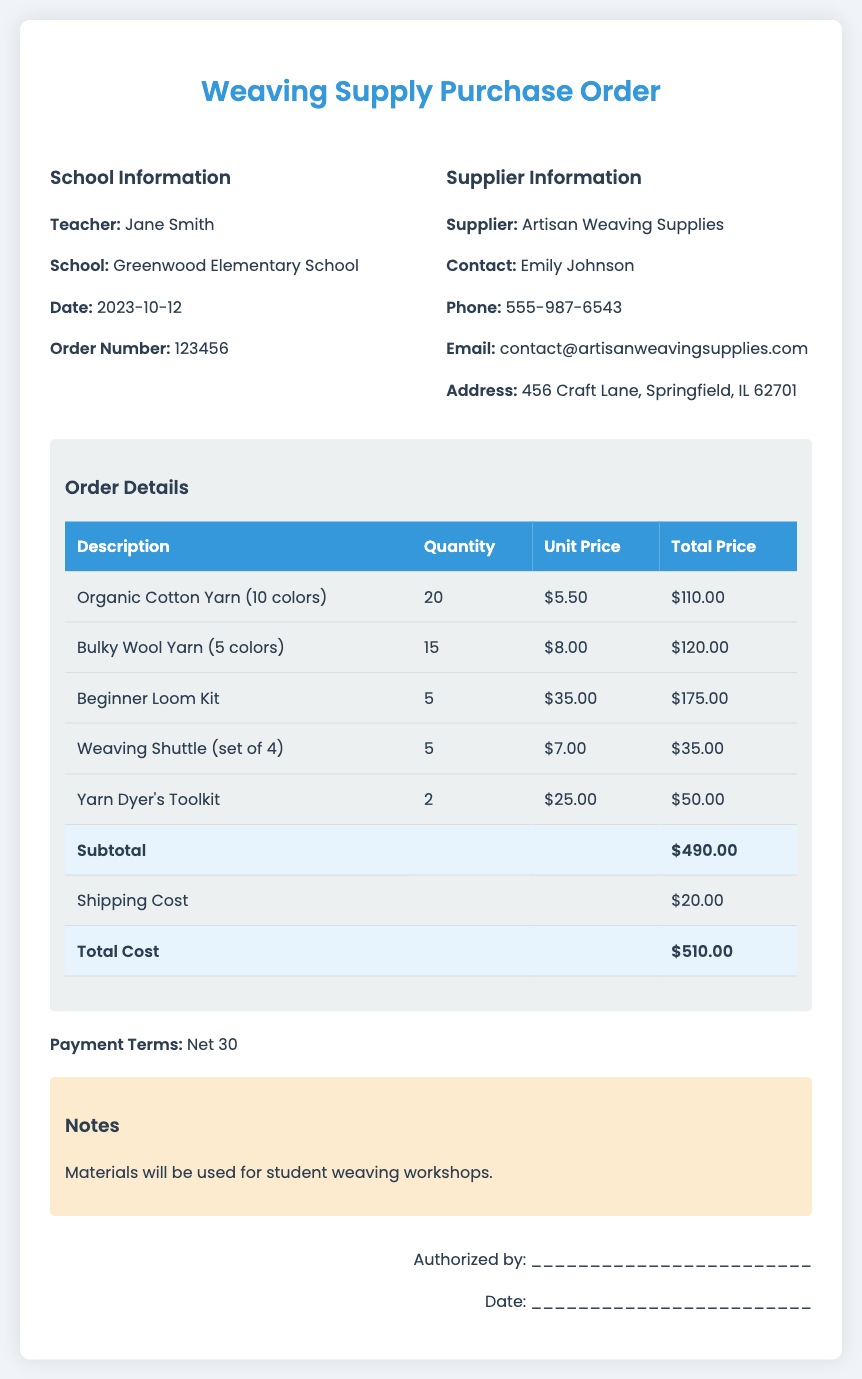What is the order number? The order number is presented in the document under the school information section.
Answer: 123456 Who is the supplier? The supplier's name is mentioned in the supplier information section of the document.
Answer: Artisan Weaving Supplies What is the total cost? The total cost is calculated and shown in the order details section at the bottom of the table.
Answer: $510.00 How many Beginner Loom Kits were ordered? The quantity ordered for each item is detailed in the order details table, corresponding to the Beginner Loom Kit.
Answer: 5 What is the shipping cost? The shipping cost is listed right before the total cost in the order details table.
Answer: $20.00 What is the payment term? The payment terms are clearly stated in the document.
Answer: Net 30 How many colors of Organic Cotton Yarn were ordered? The number of colors for each item is specified in the description section of the order details.
Answer: 10 colors What materials will be used for? The purpose of the materials is indicated in the notes section of the document.
Answer: Student weaving workshops Who is the contact person for the supplier? The contact person's name is found in the supplier information section of the document.
Answer: Emily Johnson 